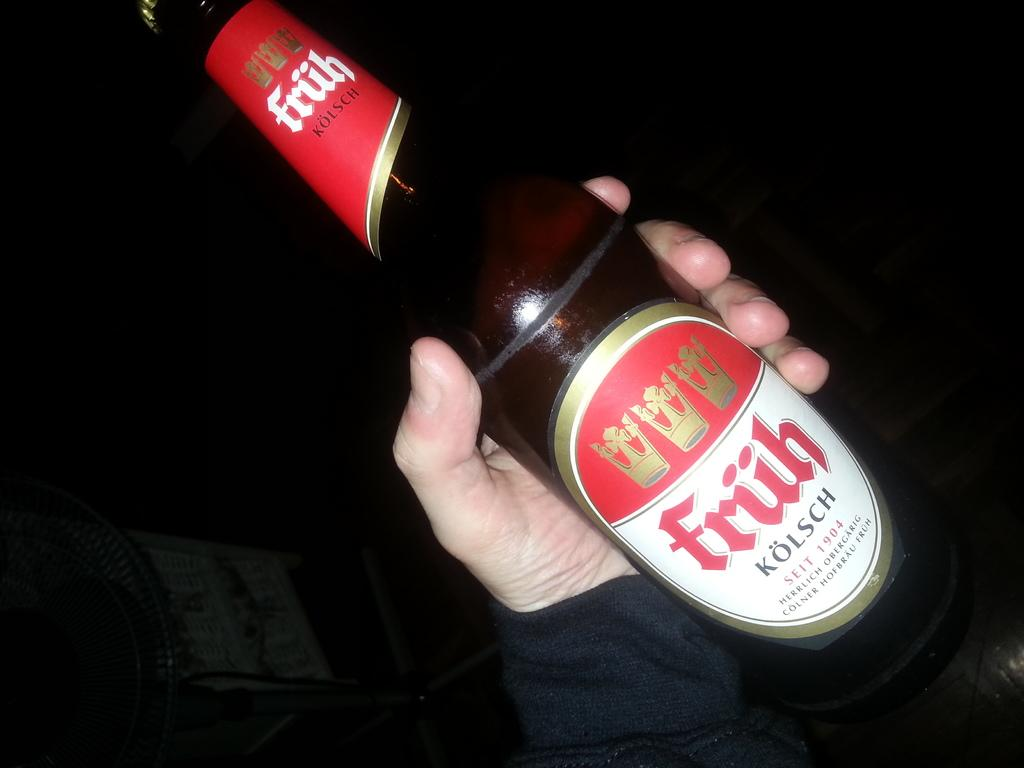What object is being held by a person in the image? There is a glass bottle in the image, and a person is holding it in their hand. Can you describe the appearance of the glass bottle? The facts provided do not give a detailed description of the glass bottle's appearance. What might the person be doing with the glass bottle? The facts provided do not give information about the person's actions or intentions with the glass bottle. What type of carriage is being pulled by the person holding the glass bottle in the image? There is no carriage present in the image; it only features a person holding a glass bottle. 